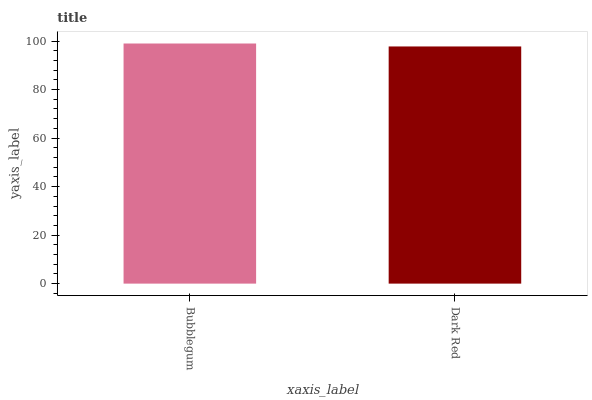Is Dark Red the minimum?
Answer yes or no. Yes. Is Bubblegum the maximum?
Answer yes or no. Yes. Is Dark Red the maximum?
Answer yes or no. No. Is Bubblegum greater than Dark Red?
Answer yes or no. Yes. Is Dark Red less than Bubblegum?
Answer yes or no. Yes. Is Dark Red greater than Bubblegum?
Answer yes or no. No. Is Bubblegum less than Dark Red?
Answer yes or no. No. Is Bubblegum the high median?
Answer yes or no. Yes. Is Dark Red the low median?
Answer yes or no. Yes. Is Dark Red the high median?
Answer yes or no. No. Is Bubblegum the low median?
Answer yes or no. No. 